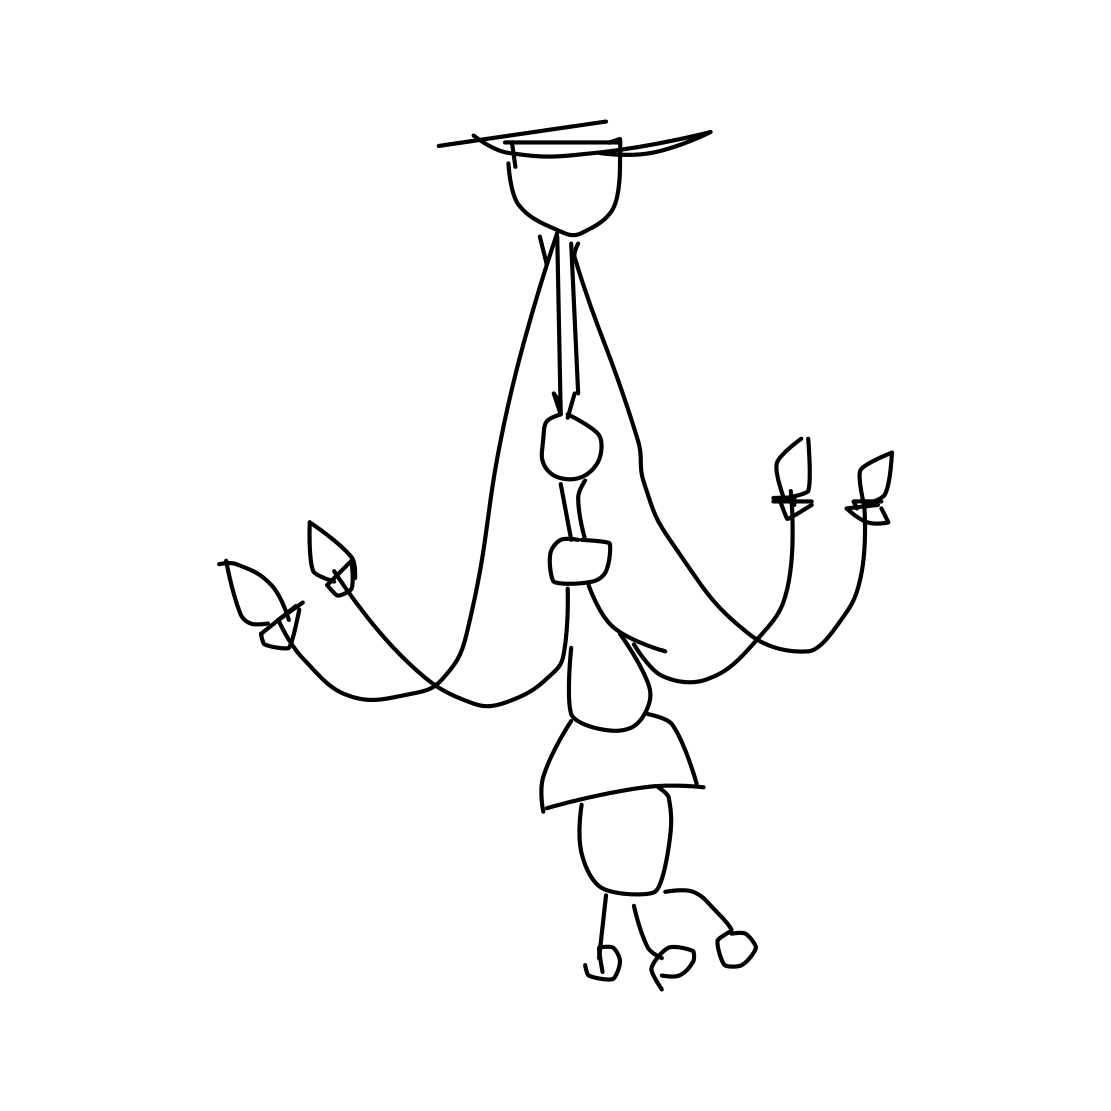Could this chandelier be functional in real life? While the chandelier's sketch provides a basic design, in reality, additional structural support and components for electrical wiring would be required for it to function as a light source in a room. 